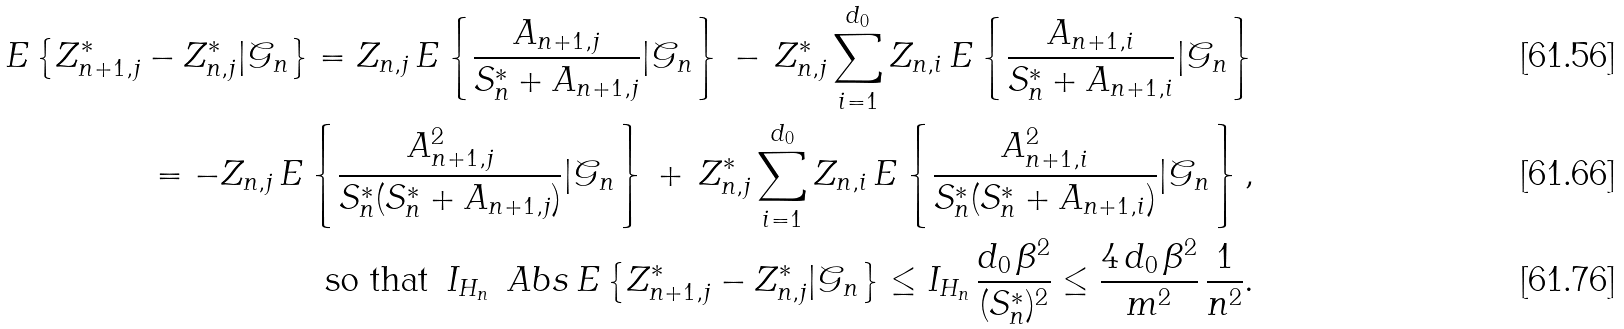<formula> <loc_0><loc_0><loc_500><loc_500>E \left \{ Z _ { n + 1 , j } ^ { * } - Z _ { n , j } ^ { * } | \mathcal { G } _ { n } \right \} = Z _ { n , j } \, E \left \{ \frac { A _ { n + 1 , j } } { S _ { n } ^ { * } + A _ { n + 1 , j } } | \mathcal { G } _ { n } \right \} \, - \, Z _ { n , j } ^ { * } \sum _ { i = 1 } ^ { d _ { 0 } } Z _ { n , i } \, E \left \{ \frac { A _ { n + 1 , i } } { S _ { n } ^ { * } + A _ { n + 1 , i } } | \mathcal { G } _ { n } \right \} \\ = - Z _ { n , j } \, E \left \{ \frac { A _ { n + 1 , j } ^ { 2 } } { S _ { n } ^ { * } ( S _ { n } ^ { * } + A _ { n + 1 , j } ) } | \mathcal { G } _ { n } \right \} \, + \, Z _ { n , j } ^ { * } \sum _ { i = 1 } ^ { d _ { 0 } } Z _ { n , i } \, E \left \{ \frac { A _ { n + 1 , i } ^ { 2 } } { S _ { n } ^ { * } ( S _ { n } ^ { * } + A _ { n + 1 , i } ) } | \mathcal { G } _ { n } \right \} , \\ \text {so that } \, I _ { H _ { n } } \, \ A b s { \, E \left \{ Z _ { n + 1 , j } ^ { * } - Z _ { n , j } ^ { * } | \mathcal { G } _ { n } \right \} } \leq I _ { H _ { n } } \, \frac { d _ { 0 } \, \beta ^ { 2 } } { ( S _ { n } ^ { * } ) ^ { 2 } } \leq \frac { 4 \, d _ { 0 } \, \beta ^ { 2 } } { m ^ { 2 } } \, \frac { 1 } { n ^ { 2 } } .</formula> 